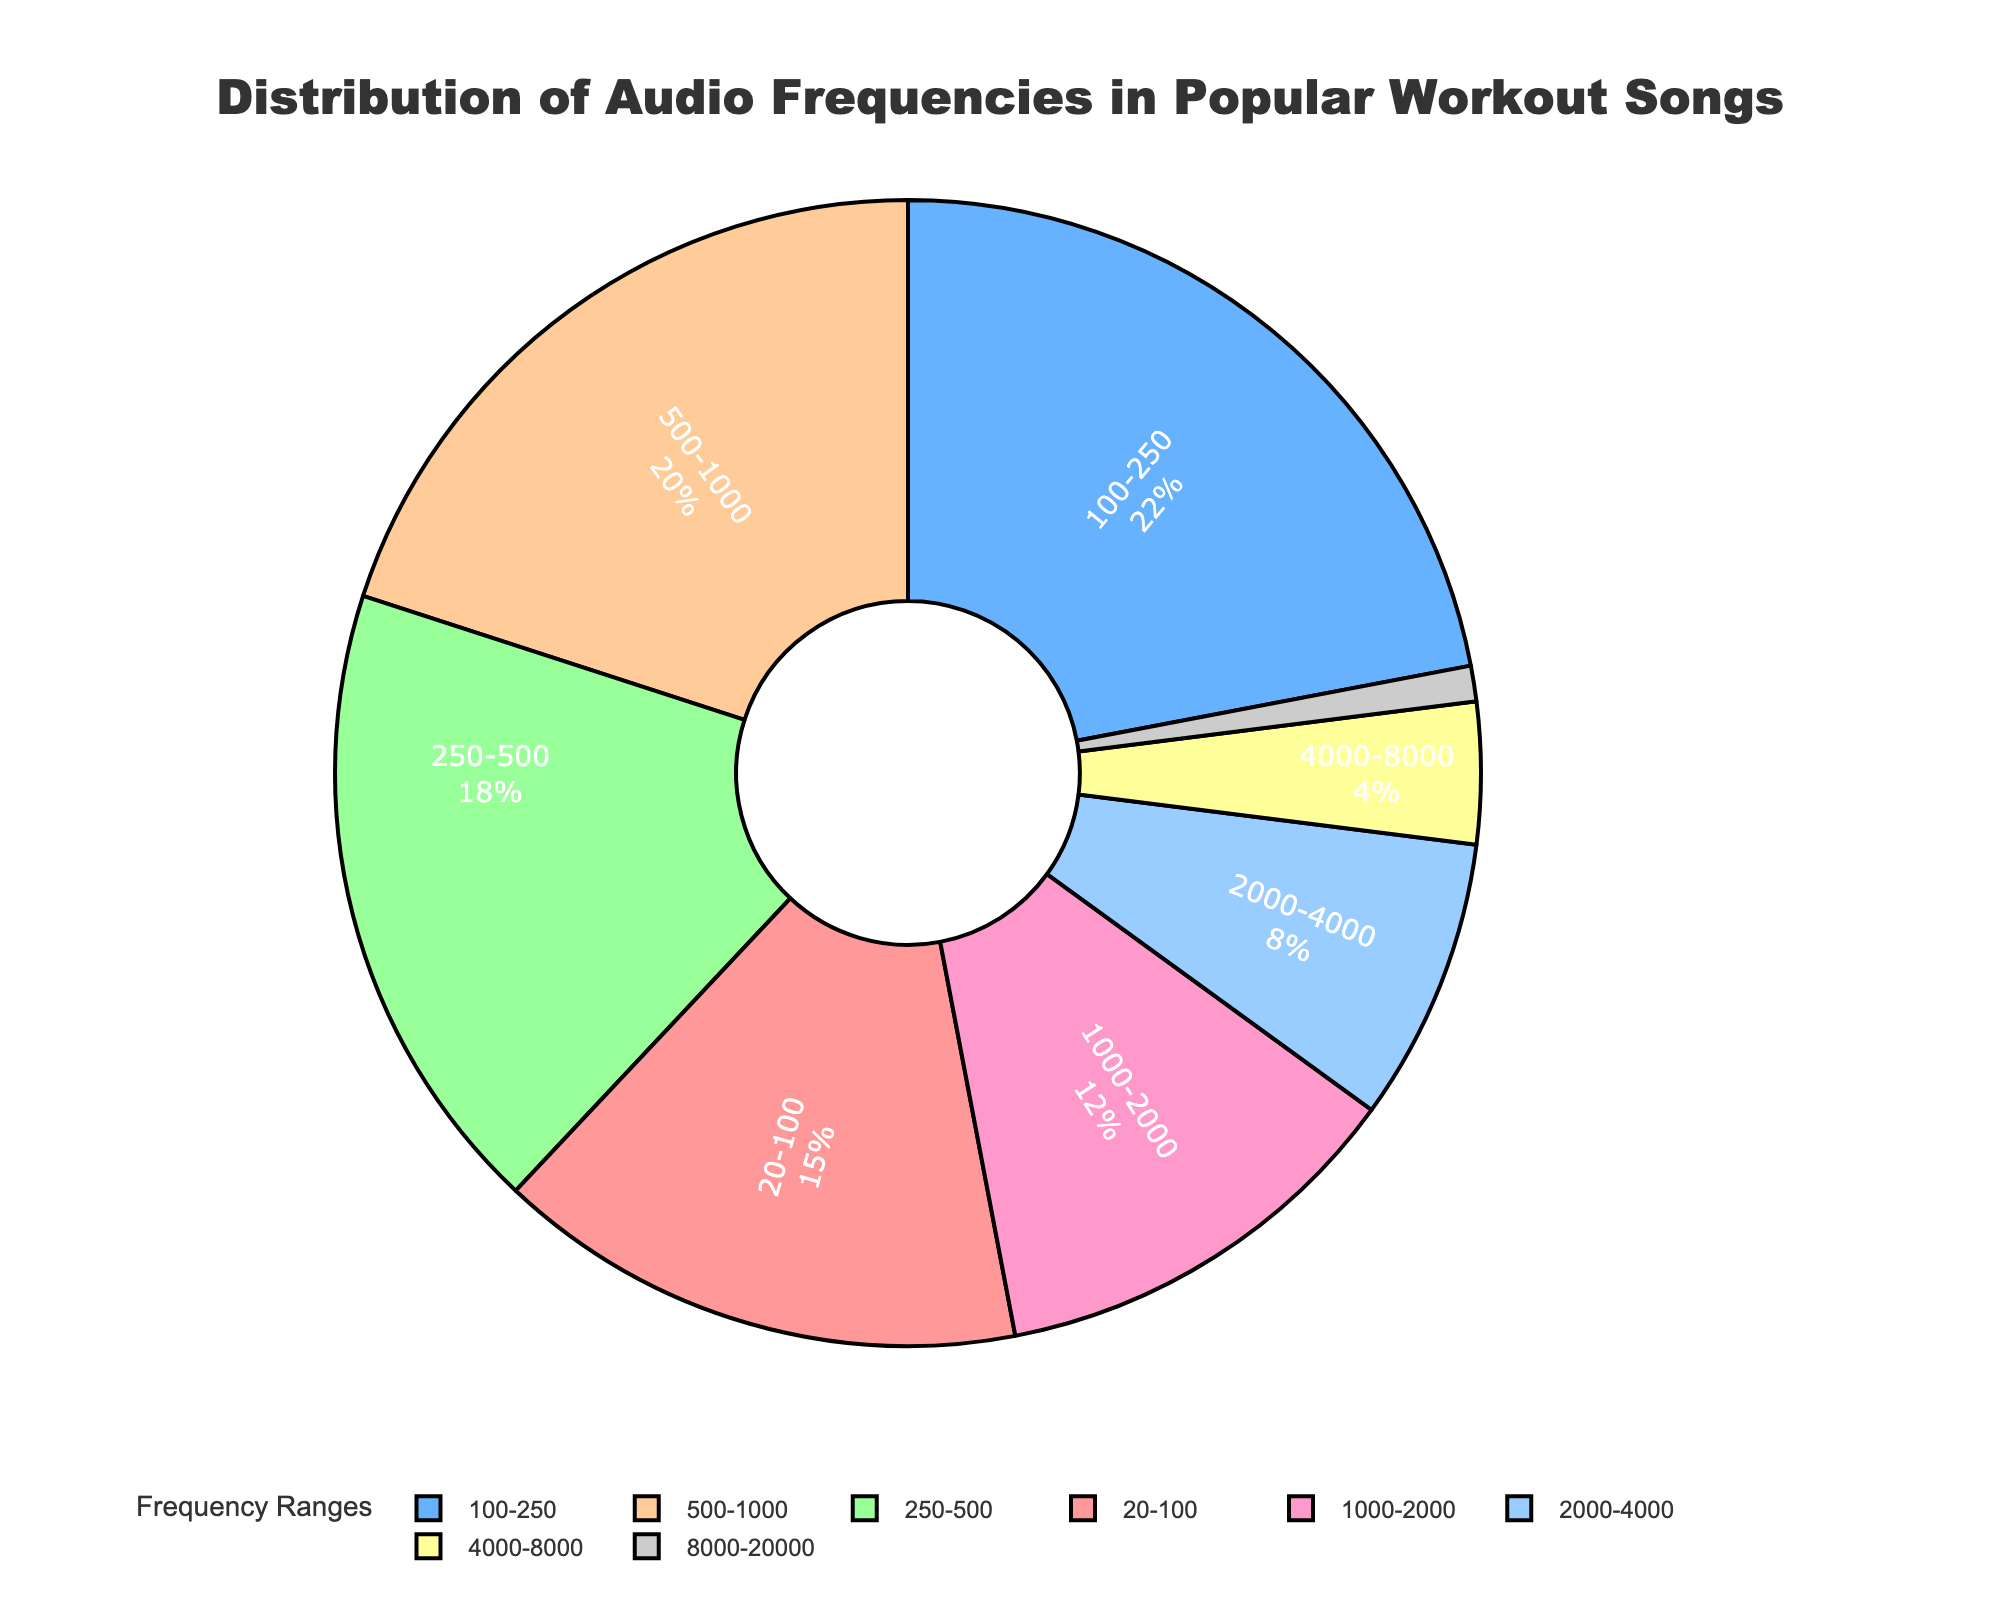What percentage of audio frequencies in popular workout songs fall in the range of 500-1000 Hz? By looking at the figure, the segment labeled 500-1000 Hz represents 20% of the whole chart.
Answer: 20% Which frequency range has the lowest representation in the chart? The segment from 8000-20000 Hz is the smallest and labeled with 1%.
Answer: 8000-20000 Hz What is the combined percentage of audio frequencies ranging from 100-500 Hz? Add the percentages of the 100-250 Hz and 250-500 Hz segments: 22% + 18% = 40%.
Answer: 40% How does the 20-100 Hz segment compare to the 500-1000 Hz segment in terms of percentage? The 20-100 Hz segment has 15%, while the 500-1000 Hz segment has 20%, so the latter is 5% higher.
Answer: The 500-1000 Hz segment has 5% more Which frequency ranges collectively account for over half of the distribution? Sum the percentages of the largest segments until surpassing 50%: 100-250 Hz (22%) + 500-1000 Hz (20%) + 250-500 Hz (18%) = 60%.
Answer: 100-250 Hz, 500-1000 Hz, 250-500 Hz What is the color of the segment representing 4000-8000 Hz? The segment for 4000-8000 Hz is represented visually in yellow.
Answer: Yellow How much larger in percentage terms is the 250-500 Hz range compared to the 2000-4000 Hz range? Subtract the percentage of the 2000-4000 Hz segment from the 250-500 Hz segment: 18% - 8% = 10%.
Answer: 10% Which two frequency ranges between 1000-2000 Hz and 500-1000 Hz have the closer representation, and what are their respective percentages? Compare 12% (1000-2000 Hz) with 20% (500-1000 Hz), the closer value is 12%.
Answer: 1000-2000 Hz (12%), 500-1000 Hz (20%) If we combine the three highest represented frequency ranges, what percentage of the total chart do they represent? Add the top three percentages: 22% (100-250 Hz) + 20% (500-1000 Hz) + 18% (250-500 Hz) = 60%.
Answer: 60% Which segment has the closest percentage to the 1000-2000 Hz segment? Compare other segments to the 1000-2000 Hz (12%): the closest is the 2000-4000 Hz (8%) at a 4% difference.
Answer: 2000-4000 Hz 